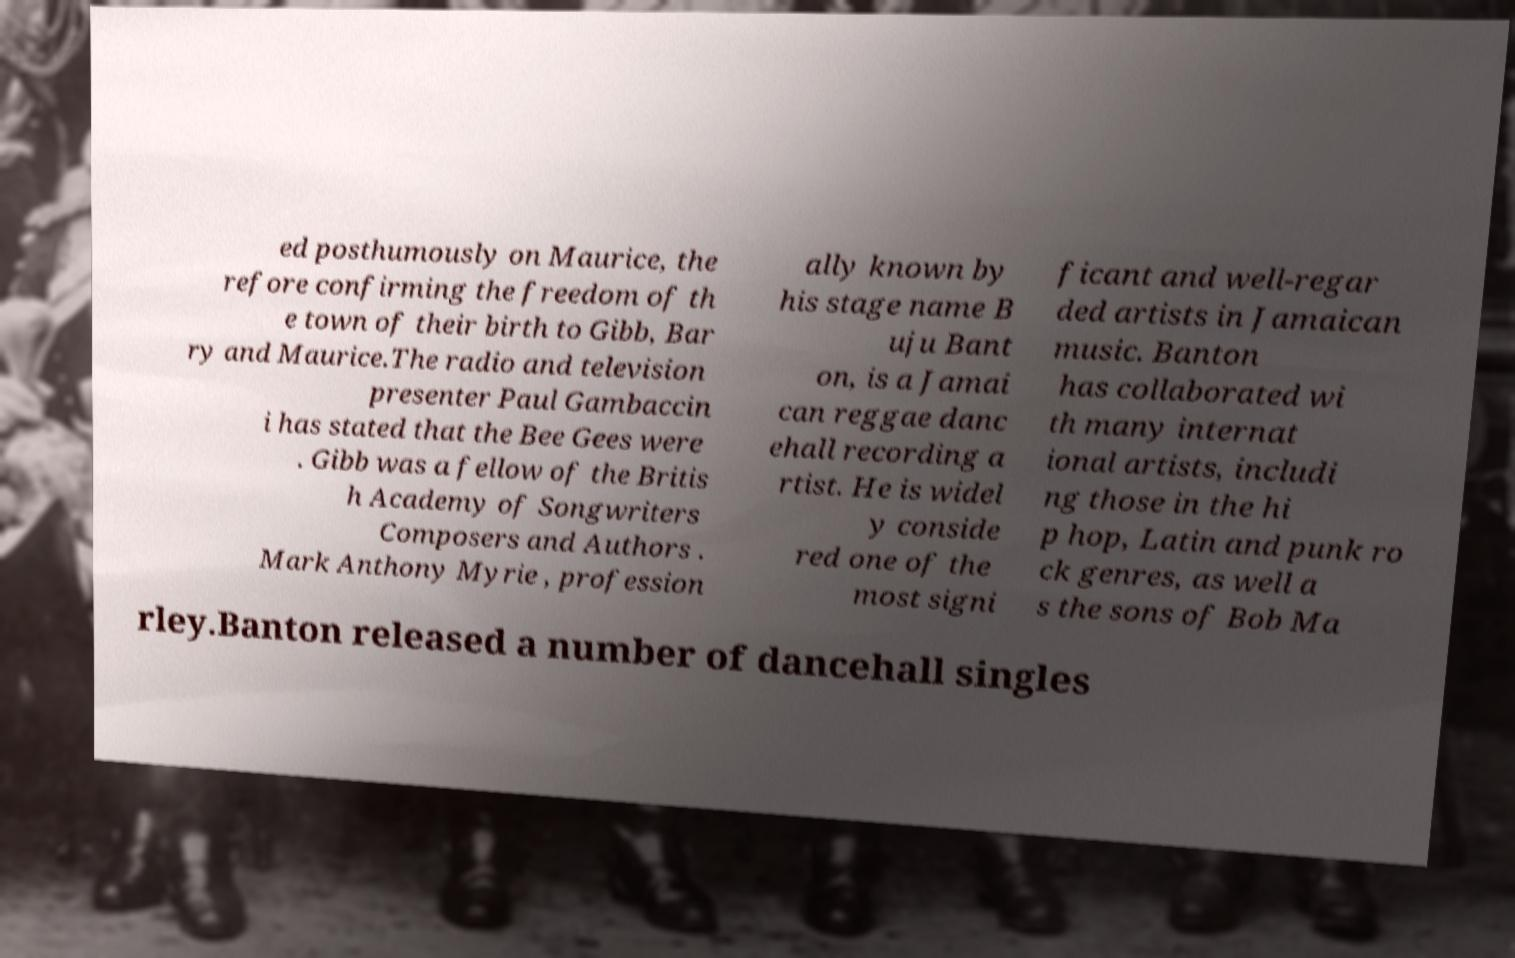Could you assist in decoding the text presented in this image and type it out clearly? ed posthumously on Maurice, the refore confirming the freedom of th e town of their birth to Gibb, Bar ry and Maurice.The radio and television presenter Paul Gambaccin i has stated that the Bee Gees were . Gibb was a fellow of the Britis h Academy of Songwriters Composers and Authors . Mark Anthony Myrie , profession ally known by his stage name B uju Bant on, is a Jamai can reggae danc ehall recording a rtist. He is widel y conside red one of the most signi ficant and well-regar ded artists in Jamaican music. Banton has collaborated wi th many internat ional artists, includi ng those in the hi p hop, Latin and punk ro ck genres, as well a s the sons of Bob Ma rley.Banton released a number of dancehall singles 